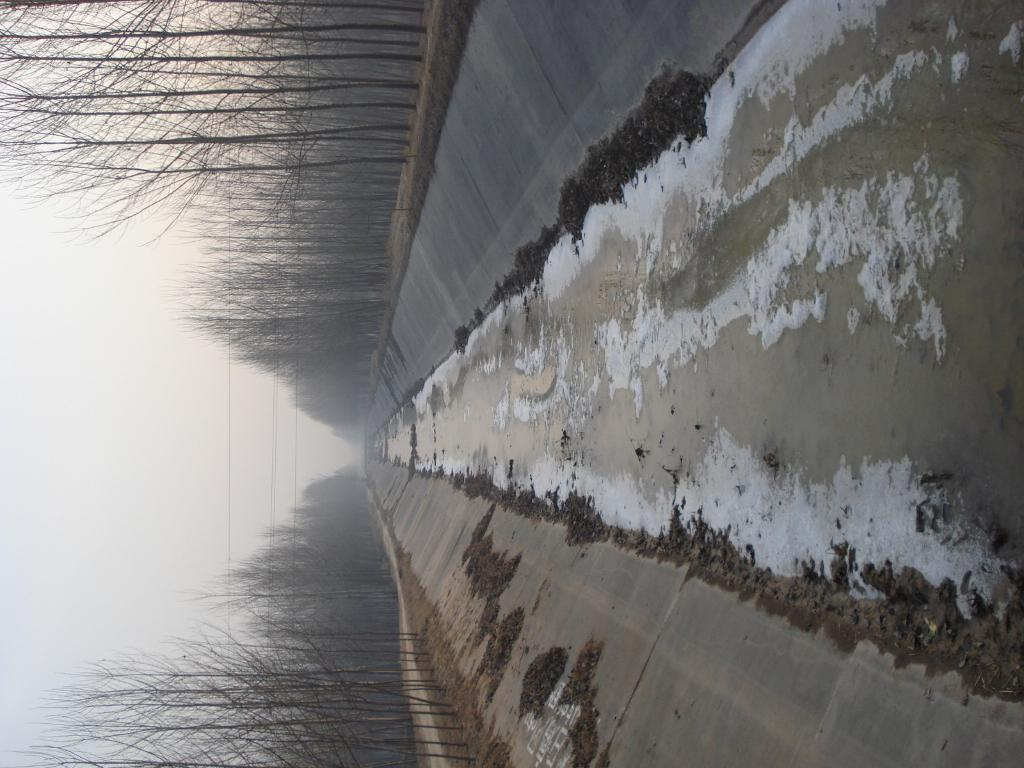What type of natural vegetation is present in the image? There is a group of trees in the image. What type of water feature can be seen in the image? There is a water canal in the image. What is visible in the background of the image? The sky is visible in the background of the image. What is the title of the basketball game being played in the image? There is no basketball game present in the image. What type of calculator is being used by the trees in the image? There is no calculator present in the image, as trees are living organisms and do not use calculators. 